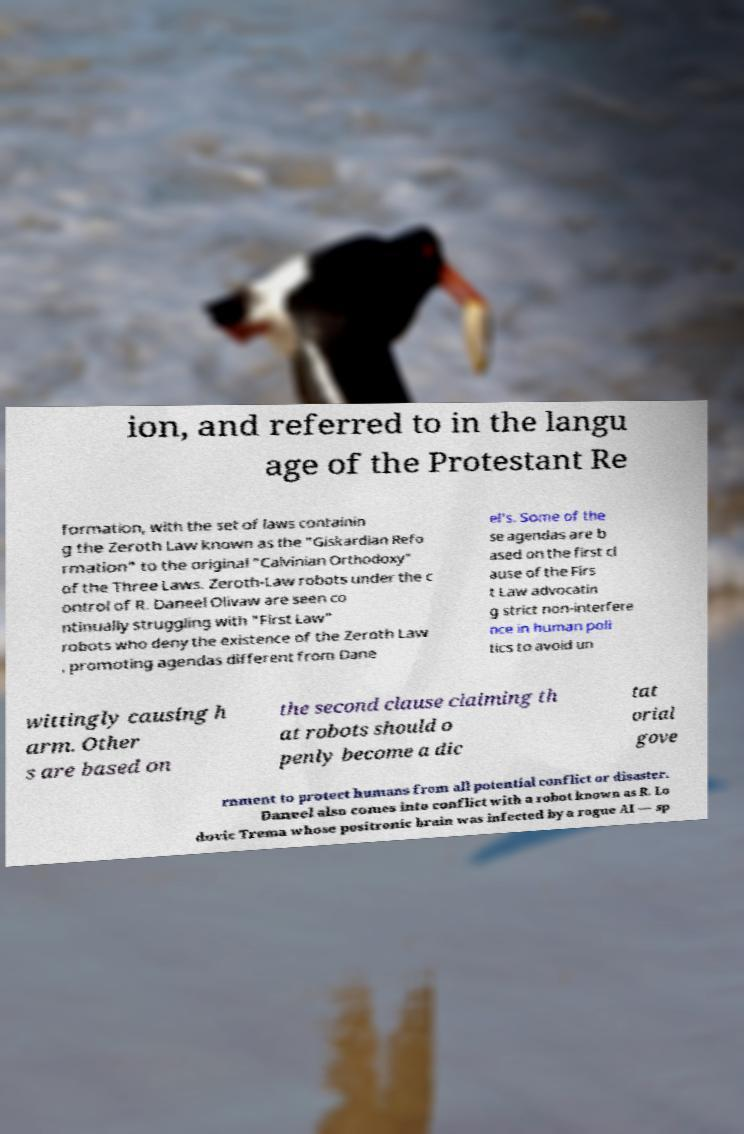Please read and relay the text visible in this image. What does it say? ion, and referred to in the langu age of the Protestant Re formation, with the set of laws containin g the Zeroth Law known as the "Giskardian Refo rmation" to the original "Calvinian Orthodoxy" of the Three Laws. Zeroth-Law robots under the c ontrol of R. Daneel Olivaw are seen co ntinually struggling with "First Law" robots who deny the existence of the Zeroth Law , promoting agendas different from Dane el's. Some of the se agendas are b ased on the first cl ause of the Firs t Law advocatin g strict non-interfere nce in human poli tics to avoid un wittingly causing h arm. Other s are based on the second clause claiming th at robots should o penly become a dic tat orial gove rnment to protect humans from all potential conflict or disaster. Daneel also comes into conflict with a robot known as R. Lo dovic Trema whose positronic brain was infected by a rogue AI — sp 